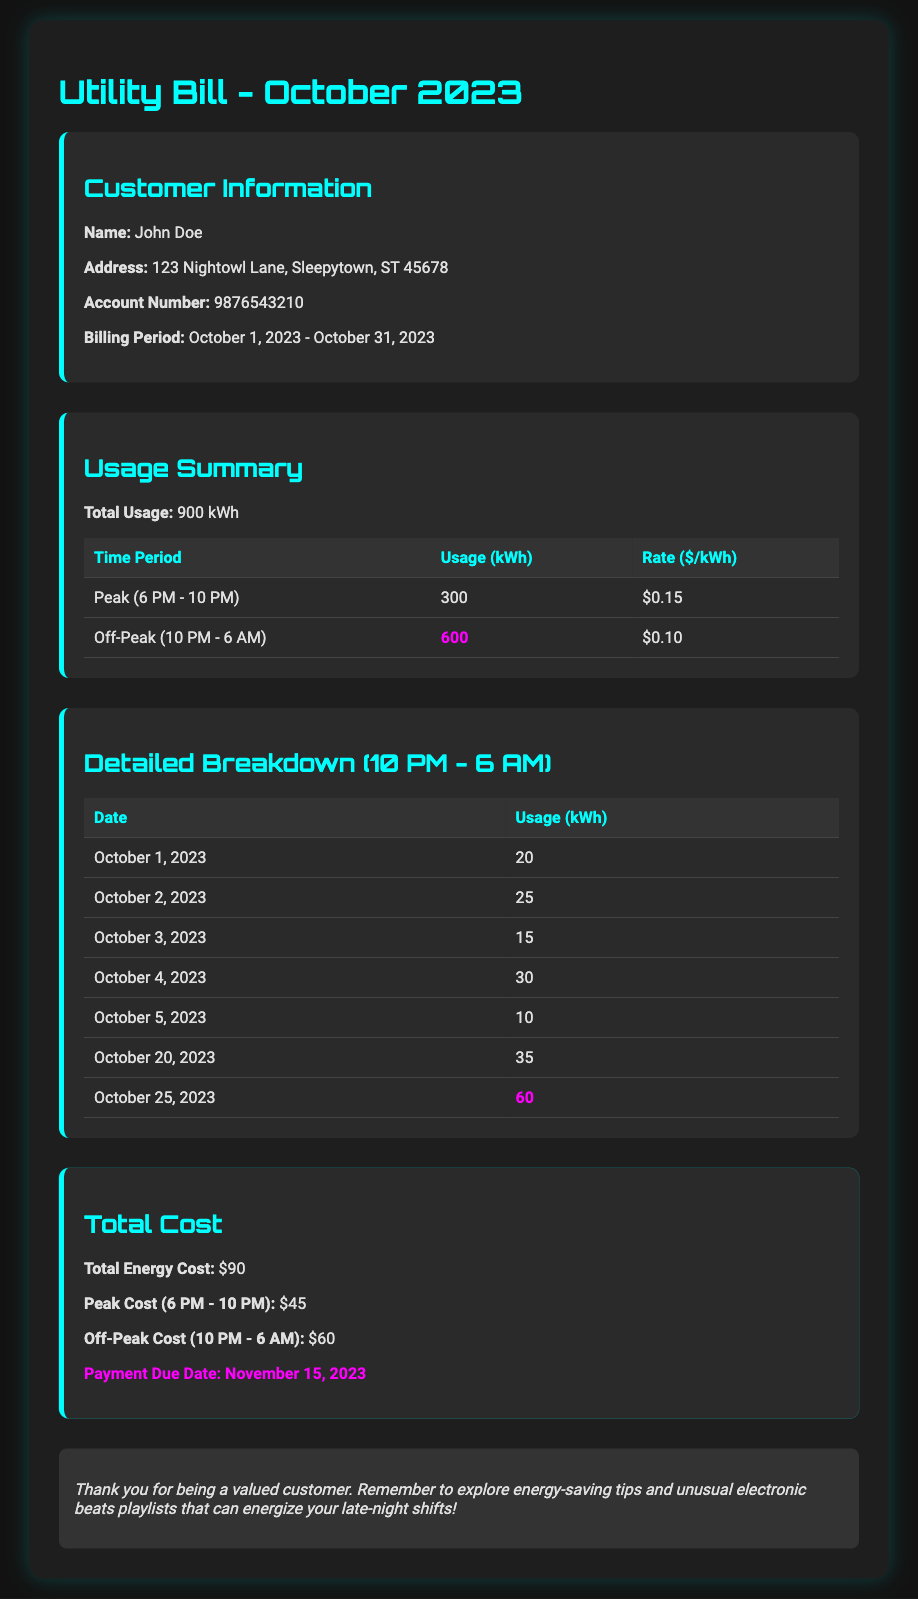What is the total electricity usage? The total electricity usage is stated in the document as 900 kWh.
Answer: 900 kWh What was the usage during off-peak hours? The usage during off-peak hours (10 PM - 6 AM) is highlighted as 600 kWh in the usage summary.
Answer: 600 kWh What is the peak cost for the month? The peak cost for the month is specified as $45 in the total cost section.
Answer: $45 On which date was the highest off-peak usage recorded? The highest off-peak usage is highlighted for October 25, 2023, with 60 kWh.
Answer: October 25, 2023 What is the total energy cost? The total energy cost according to the document is $90.
Answer: $90 How much was the usage on October 4, 2023? The usage on October 4, 2023, is explicitly given as 30 kWh in the detailed breakdown.
Answer: 30 kWh What is the payment due date for this bill? The payment due date is highlighted in the total cost section as November 15, 2023.
Answer: November 15, 2023 Which time period has the lowest rate? The time period with the lowest rate is the off-peak hours, as stated at $0.10 per kWh.
Answer: Off-Peak (10 PM - 6 AM) Who is the customer? The customer's name is stated as John Doe in the customer information section.
Answer: John Doe 